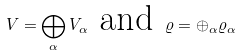<formula> <loc_0><loc_0><loc_500><loc_500>V = \bigoplus _ { \alpha } V _ { \alpha } \text { and } \varrho = \oplus _ { \alpha } \varrho _ { \alpha }</formula> 